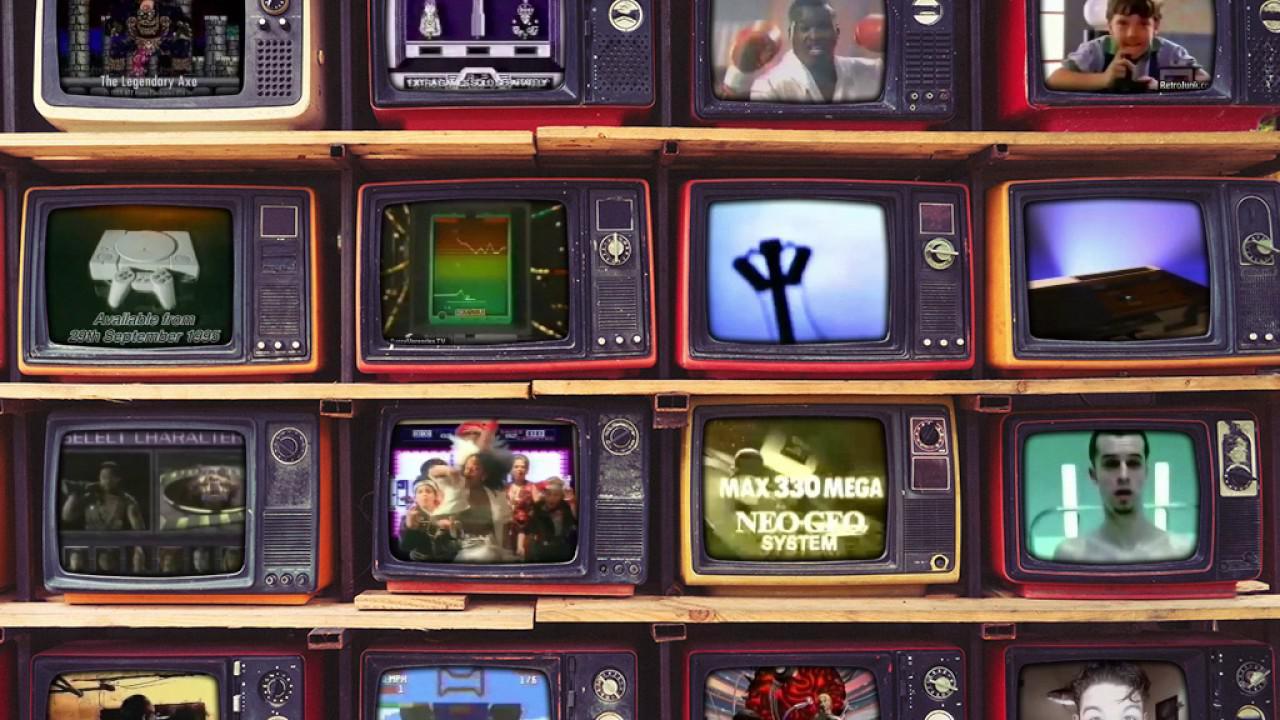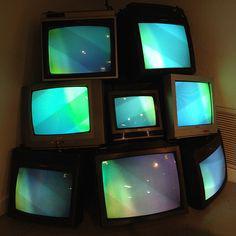The first image is the image on the left, the second image is the image on the right. Given the left and right images, does the statement "There are exactly five televisions in the image on the left." hold true? Answer yes or no. No. The first image is the image on the left, the second image is the image on the right. For the images displayed, is the sentence "In one image, an arrangement of old televisions that are turned on to various channels is stacked at least three high, while a second image shows exactly five television or computer screens." factually correct? Answer yes or no. No. 